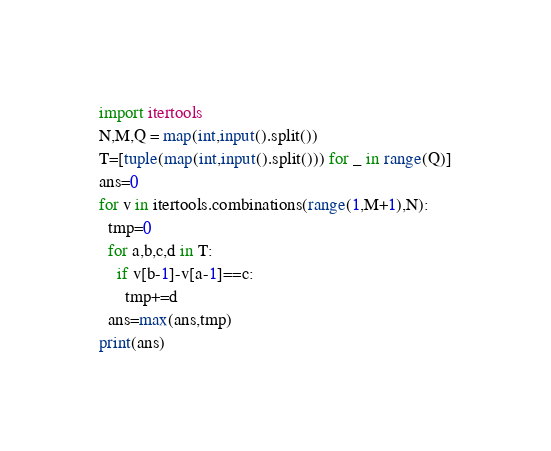Convert code to text. <code><loc_0><loc_0><loc_500><loc_500><_Python_>import itertools
N,M,Q = map(int,input().split())
T=[tuple(map(int,input().split())) for _ in range(Q)]
ans=0
for v in itertools.combinations(range(1,M+1),N):
  tmp=0
  for a,b,c,d in T:
    if v[b-1]-v[a-1]==c:
      tmp+=d
  ans=max(ans,tmp)
print(ans)</code> 